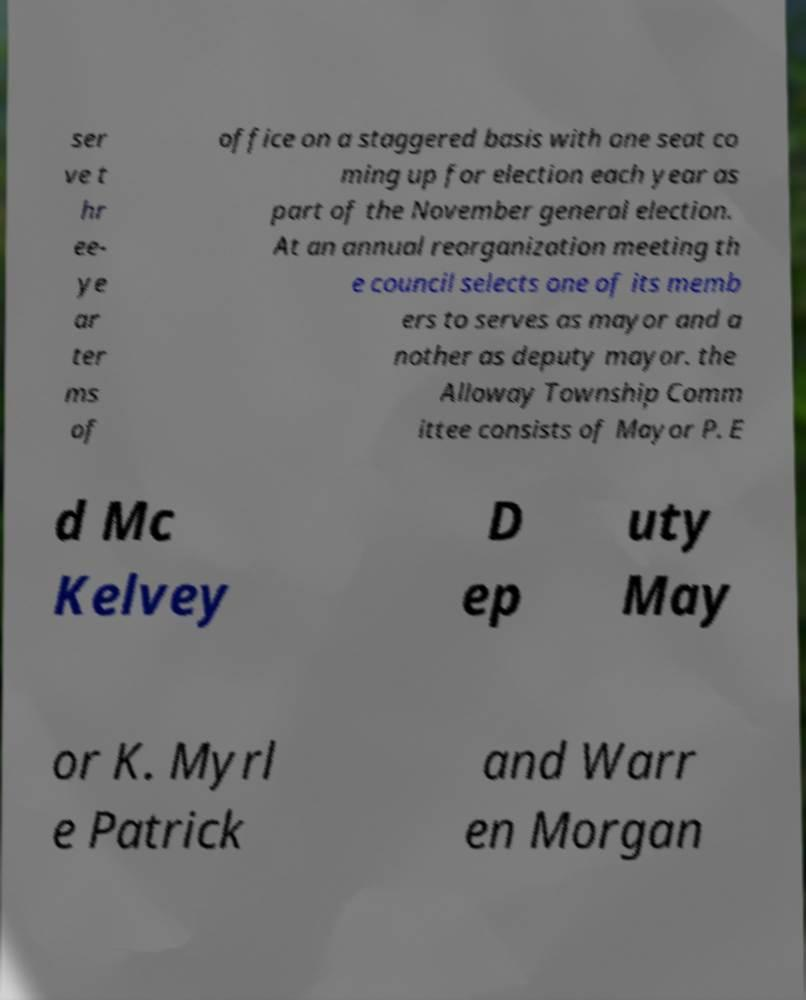There's text embedded in this image that I need extracted. Can you transcribe it verbatim? ser ve t hr ee- ye ar ter ms of office on a staggered basis with one seat co ming up for election each year as part of the November general election. At an annual reorganization meeting th e council selects one of its memb ers to serves as mayor and a nother as deputy mayor. the Alloway Township Comm ittee consists of Mayor P. E d Mc Kelvey D ep uty May or K. Myrl e Patrick and Warr en Morgan 